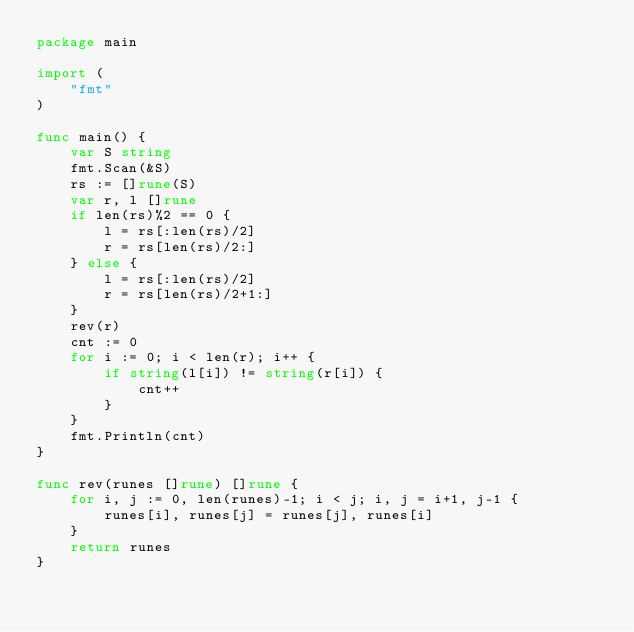<code> <loc_0><loc_0><loc_500><loc_500><_Go_>package main

import (
	"fmt"
)

func main() {
	var S string
	fmt.Scan(&S)
	rs := []rune(S)
	var r, l []rune
	if len(rs)%2 == 0 {
		l = rs[:len(rs)/2]
		r = rs[len(rs)/2:]
	} else {
		l = rs[:len(rs)/2]
		r = rs[len(rs)/2+1:]
	}
	rev(r)
	cnt := 0
	for i := 0; i < len(r); i++ {
		if string(l[i]) != string(r[i]) {
			cnt++
		}
	}
	fmt.Println(cnt)
}

func rev(runes []rune) []rune {
	for i, j := 0, len(runes)-1; i < j; i, j = i+1, j-1 {
		runes[i], runes[j] = runes[j], runes[i]
	}
	return runes
}
</code> 